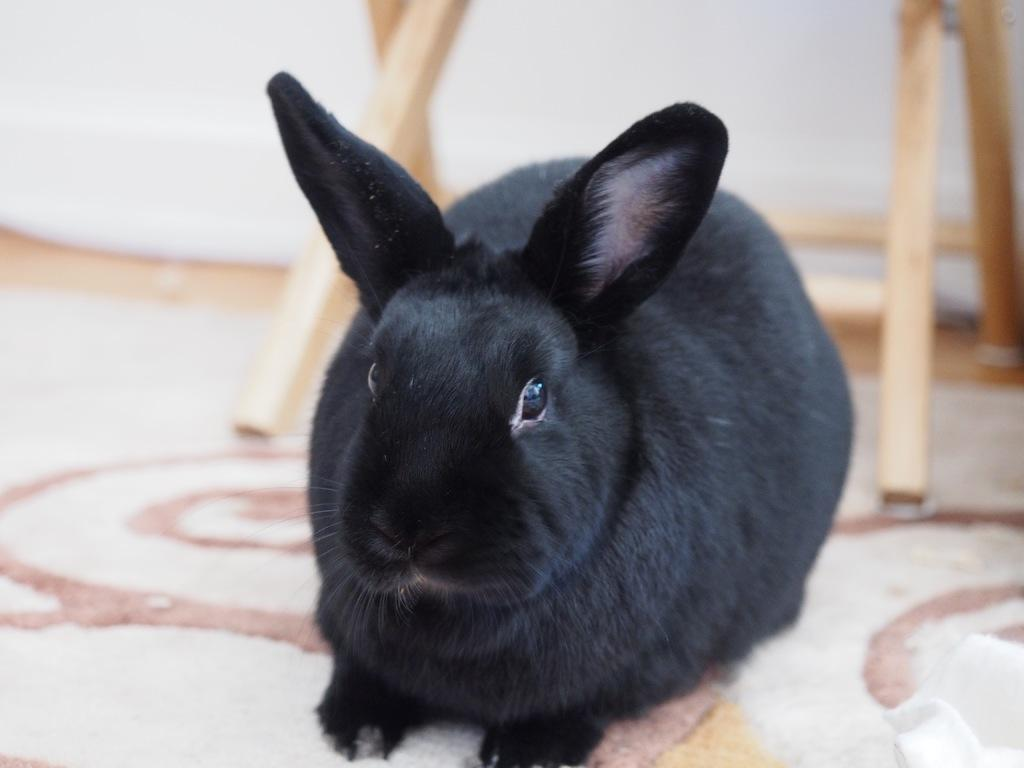What animal is in the foreground of the image? There is a black rabbit in the foreground of the image. What is the black rabbit resting on? The black rabbit is on a floor mat. What can be seen in the background of the image? There is a table and a white object in the background of the image. Which direction is the rabbit facing in the image? The provided facts do not mention the direction the rabbit is facing, so it cannot be determined from the image. 